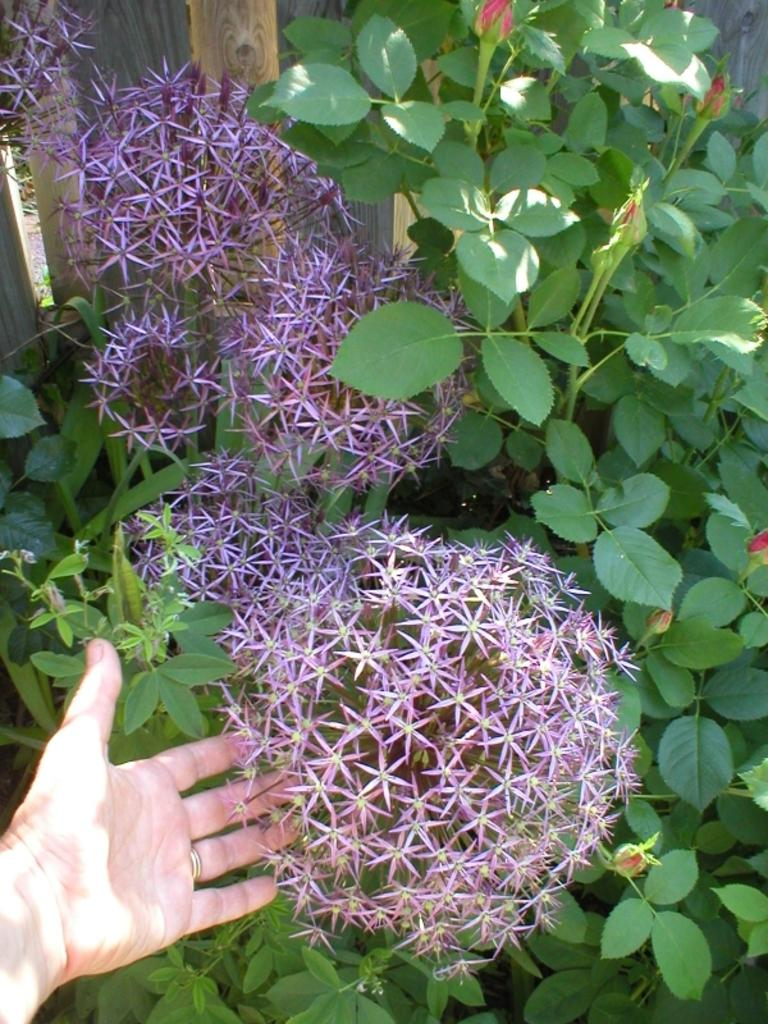What part of a person can be seen in the image? There is a person's hand in the image. What type of plants are visible in the image? There are flowers and leaves in the image. What colors are the flowers? The flowers are in purple and red colors. What color are the leaves? The leaves are green in color. What can be seen in the background of the image? There is wooden fencing in the background of the image. What type of polish is being applied to the zoo animals in the image? There is no polish or zoo animals present in the image. What type of prose can be seen written on the leaves in the image? There is no prose written on the leaves in the image; they are simply green leaves. 